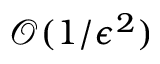<formula> <loc_0><loc_0><loc_500><loc_500>\mathcal { O } ( 1 / \epsilon ^ { 2 } )</formula> 